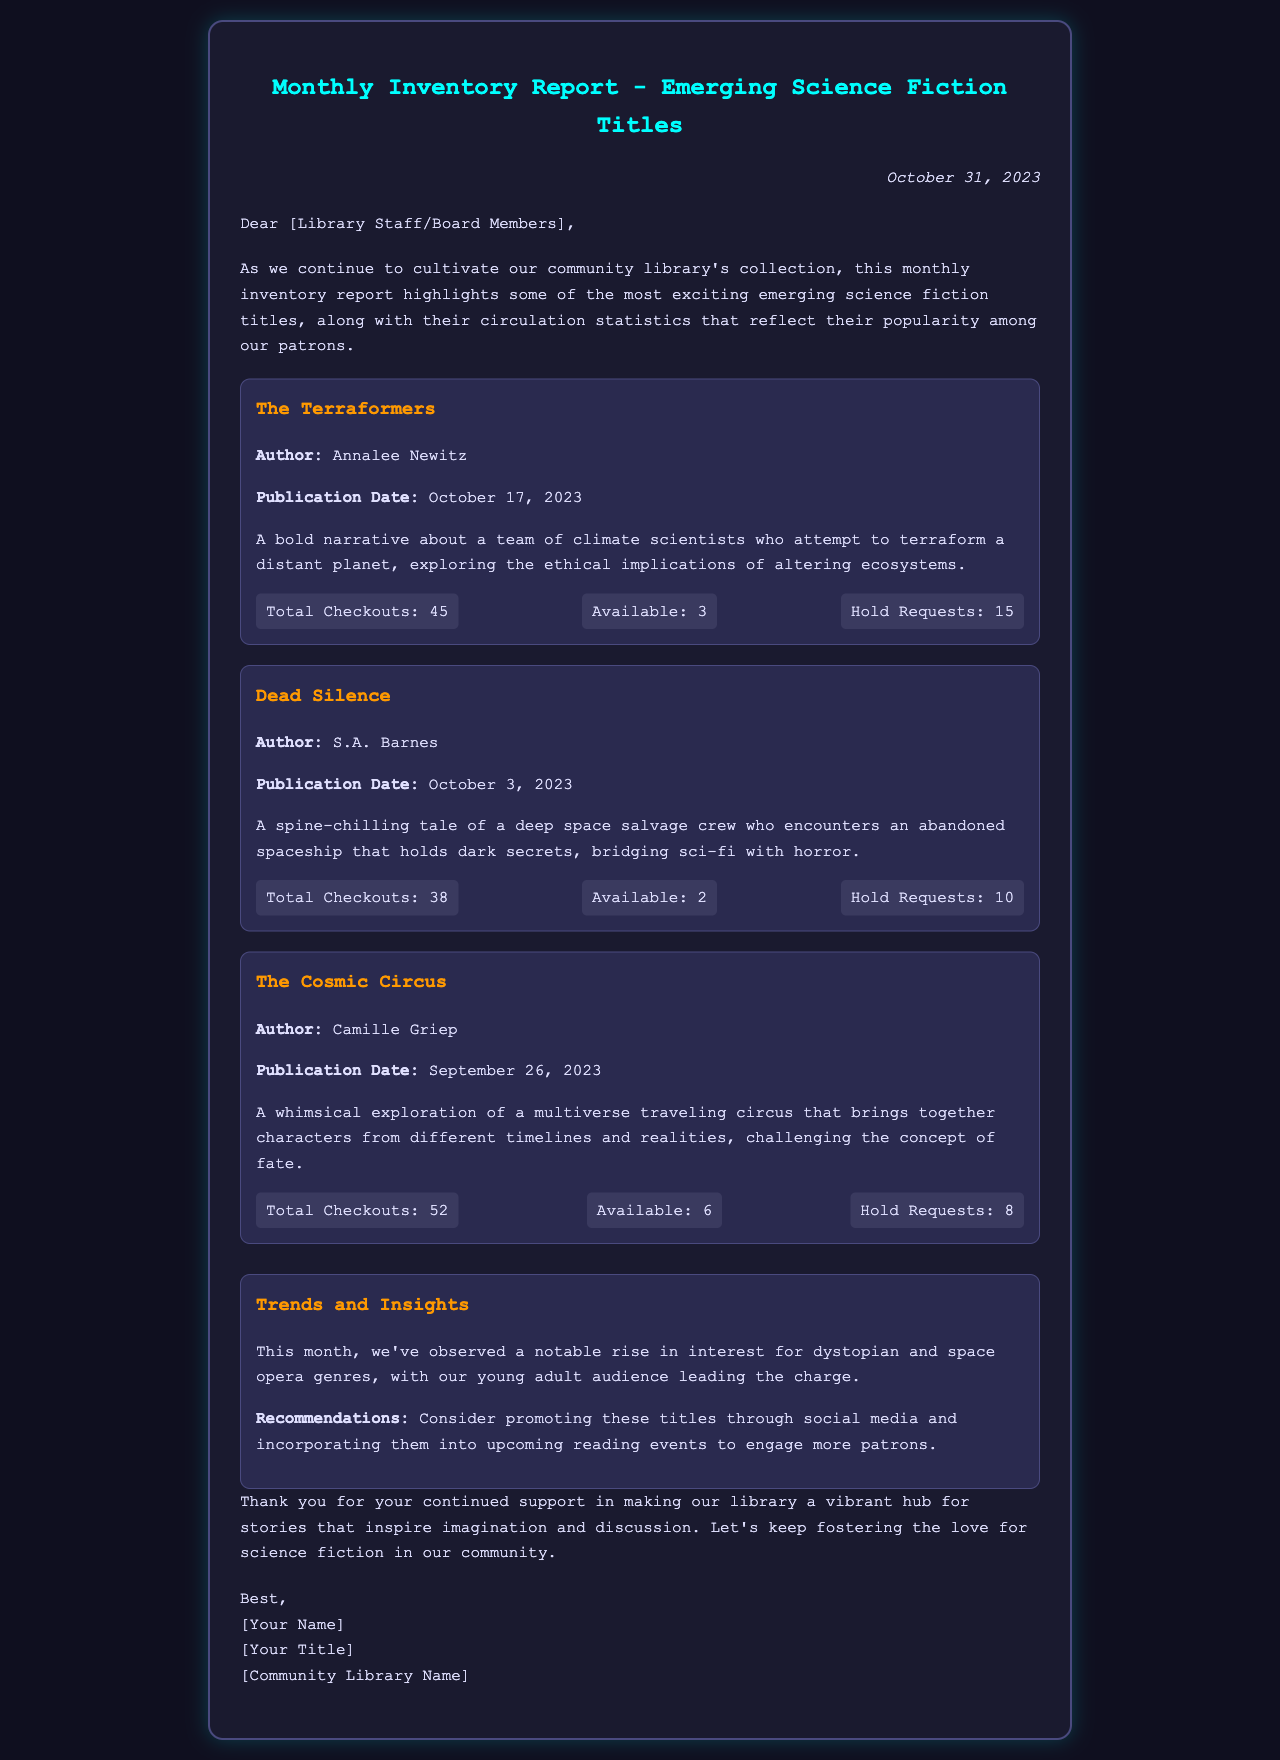What is the title of the first highlighted book? The first highlighted book is listed as "The Terraformers" in the report.
Answer: The Terraformers Who is the author of "Dead Silence"? The document states that "Dead Silence" was written by S.A. Barnes.
Answer: S.A. Barnes What is the total number of checkouts for "The Cosmic Circus"? The report shows that "The Cosmic Circus" has a total of 52 checkouts recorded.
Answer: 52 How many hold requests are there for "The Terraformers"? The document indicates that there are 15 hold requests for "The Terraformers".
Answer: 15 What genre is currently trending according to the report? The report mentions that there is a notable rise in interest for dystopian and space opera genres.
Answer: Dystopian and space opera What is the publication date of "The Cosmic Circus"? The document states that "The Cosmic Circus" was published on September 26, 2023.
Answer: September 26, 2023 How many available copies are there for "Dead Silence"? The report shows that there are 2 available copies of "Dead Silence".
Answer: 2 What date was the inventory report created? The document indicates that the inventory report is dated October 31, 2023.
Answer: October 31, 2023 What recommendation is made for promoting the highlighted titles? The document suggests promoting these titles through social media and incorporating them into upcoming reading events.
Answer: Promote through social media and reading events 